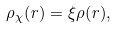Convert formula to latex. <formula><loc_0><loc_0><loc_500><loc_500>\rho _ { \chi } ( r ) = \xi \rho ( r ) ,</formula> 